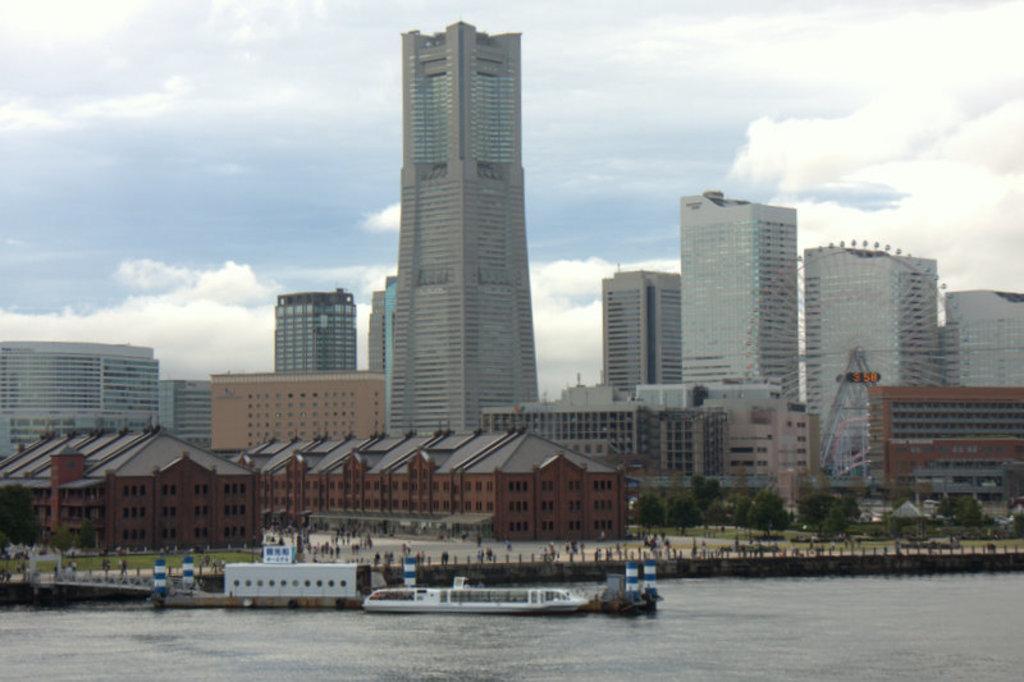Can you describe this image briefly? In this image I can see few buildings, windows, trees, water, few people around and the water. The sky is in blue and white color. 